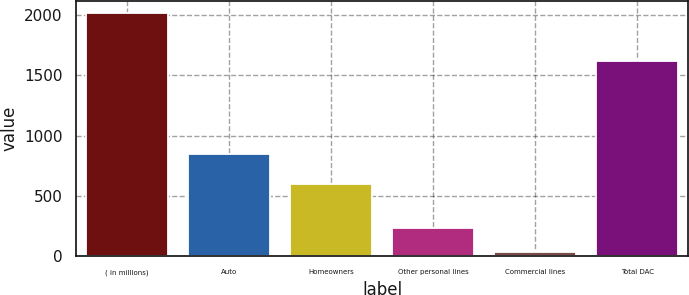Convert chart. <chart><loc_0><loc_0><loc_500><loc_500><bar_chart><fcel>( in millions)<fcel>Auto<fcel>Homeowners<fcel>Other personal lines<fcel>Commercial lines<fcel>Total DAC<nl><fcel>2018<fcel>845<fcel>599<fcel>231.5<fcel>33<fcel>1618<nl></chart> 